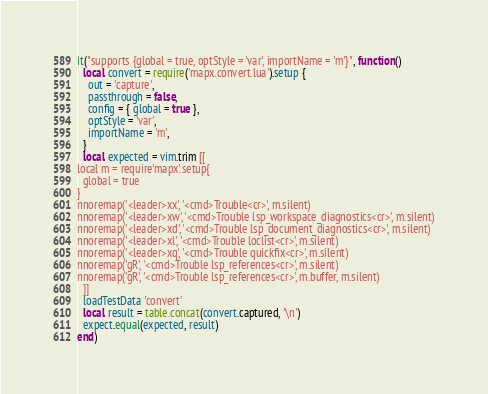Convert code to text. <code><loc_0><loc_0><loc_500><loc_500><_Lua_>it("supports {global = true, optStyle = 'var', importName = 'm'}", function()
  local convert = require('mapx.convert.lua').setup {
    out = 'capture',
    passthrough = false,
    config = { global = true },
    optStyle = 'var',
    importName = 'm',
  }
  local expected = vim.trim [[
local m = require'mapx'.setup{
  global = true
}
nnoremap('<leader>xx', '<cmd>Trouble<cr>', m.silent)
nnoremap('<leader>xw', '<cmd>Trouble lsp_workspace_diagnostics<cr>', m.silent)
nnoremap('<leader>xd', '<cmd>Trouble lsp_document_diagnostics<cr>', m.silent)
nnoremap('<leader>xl', '<cmd>Trouble loclist<cr>', m.silent)
nnoremap('<leader>xq', '<cmd>Trouble quickfix<cr>', m.silent)
nnoremap('gR', '<cmd>Trouble lsp_references<cr>', m.silent)
nnoremap('gR', '<cmd>Trouble lsp_references<cr>', m.buffer, m.silent)
  ]]
  loadTestData 'convert'
  local result = table.concat(convert.captured, '\n')
  expect.equal(expected, result)
end)
</code> 